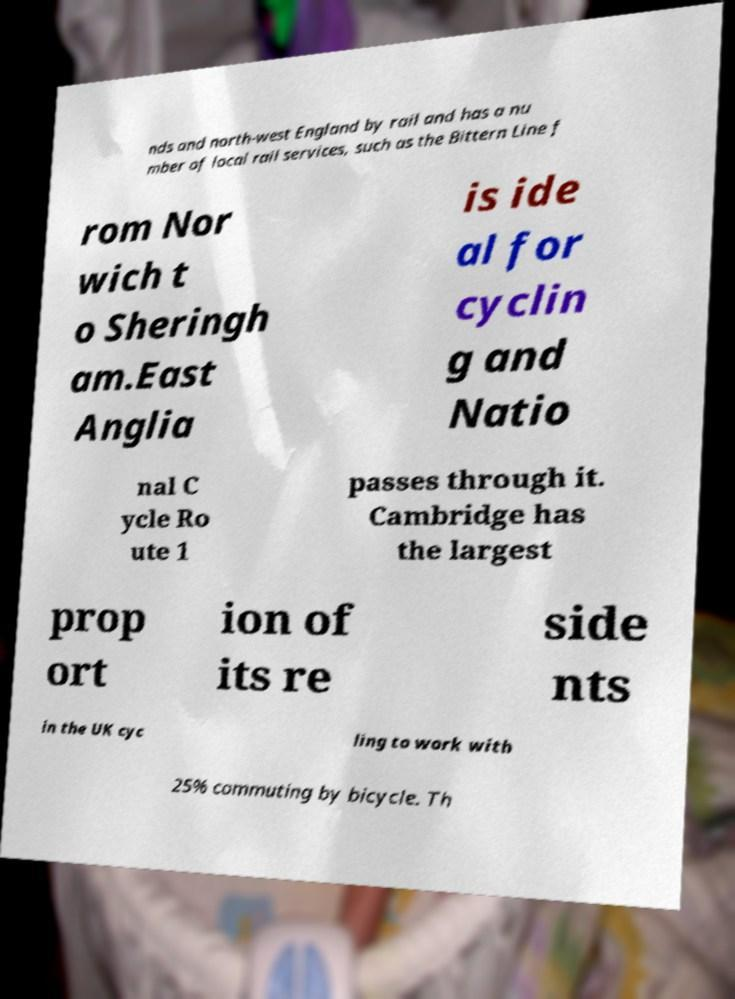Could you assist in decoding the text presented in this image and type it out clearly? nds and north-west England by rail and has a nu mber of local rail services, such as the Bittern Line f rom Nor wich t o Sheringh am.East Anglia is ide al for cyclin g and Natio nal C ycle Ro ute 1 passes through it. Cambridge has the largest prop ort ion of its re side nts in the UK cyc ling to work with 25% commuting by bicycle. Th 